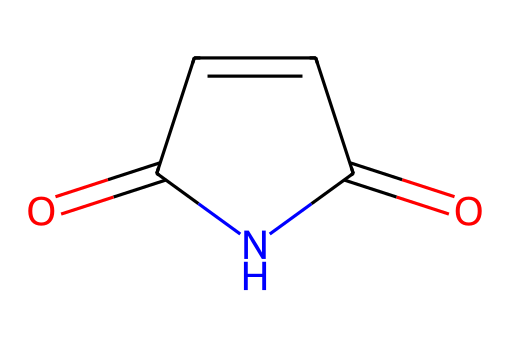What is the molecular formula of maleimide? By interpreting the SMILES notation, we can identify the atoms present in the structure. The chemical contains 4 carbon atoms, 4 hydrogen atoms, 2 oxygen atoms, and 1 nitrogen atom. Thus, the molecular formula is C4H4N2O2.
Answer: C4H4N2O2 How many nitrogen atoms are in maleimide? From the structure indicated in the SMILES, we see the presence of 1 nitrogen atom, denoted by the 'N' in the representation.
Answer: 1 What type of functional groups are present in maleimide? By examining the chemical structure, we see that maleimide contains both a carbonyl group (C=O) and an imide functional group (C=O and -NH-). This is characteristic of imides, which are defined by such groups.
Answer: carbonyl and imide Is maleimide a saturated or unsaturated compound? The presence of a double bond in the SMILES notation (C=C) indicates that there is unsaturation in the molecule. Thus, maleimide is classified as an unsaturated compound.
Answer: unsaturated What type of reaction might maleimide undergo? Given that maleimide has a double bond and functional groups like the carbonyl and imide, it can undergo addition reactions typical of unsaturated compounds as well as nucleophilic acyl substitution due to its imide character.
Answer: addition and substitution What does the imide structure imply about its reactivity? Imides, such as maleimide, are known to be relatively stable but can undergo hydrolysis, especially under acidic or basic conditions. The N-H bond can also serve as a site for nucleophilic attack, promoting further reactions.
Answer: stable with nucleophilic reactivity What is a common application of maleimide in products? Maleimide is commonly used in hair care products for its ability to form cross-links between proteins, improving hair strength and stability. This is particularly valued by those focused on maintaining elegant hairstyles.
Answer: hair care products 